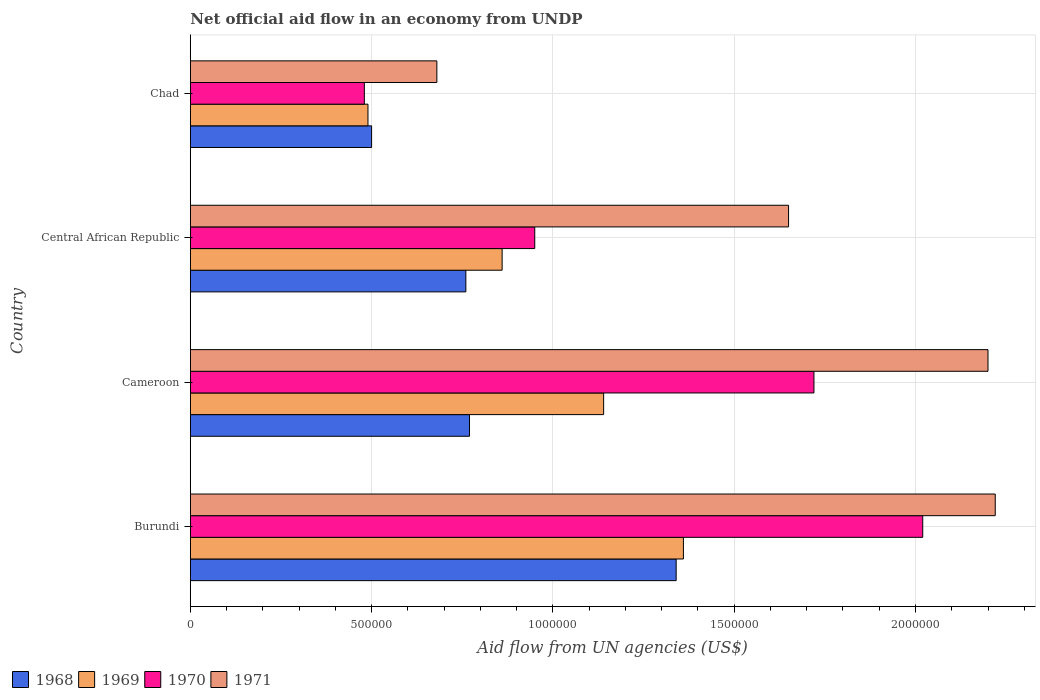How many different coloured bars are there?
Provide a succinct answer. 4. How many groups of bars are there?
Your answer should be very brief. 4. Are the number of bars per tick equal to the number of legend labels?
Offer a very short reply. Yes. Are the number of bars on each tick of the Y-axis equal?
Ensure brevity in your answer.  Yes. How many bars are there on the 4th tick from the bottom?
Make the answer very short. 4. What is the label of the 3rd group of bars from the top?
Ensure brevity in your answer.  Cameroon. In how many cases, is the number of bars for a given country not equal to the number of legend labels?
Offer a very short reply. 0. What is the net official aid flow in 1971 in Central African Republic?
Make the answer very short. 1.65e+06. Across all countries, what is the maximum net official aid flow in 1970?
Provide a short and direct response. 2.02e+06. Across all countries, what is the minimum net official aid flow in 1971?
Ensure brevity in your answer.  6.80e+05. In which country was the net official aid flow in 1971 maximum?
Make the answer very short. Burundi. In which country was the net official aid flow in 1968 minimum?
Your answer should be very brief. Chad. What is the total net official aid flow in 1968 in the graph?
Make the answer very short. 3.37e+06. What is the difference between the net official aid flow in 1971 in Cameroon and that in Chad?
Give a very brief answer. 1.52e+06. What is the difference between the net official aid flow in 1969 in Chad and the net official aid flow in 1970 in Cameroon?
Your answer should be compact. -1.23e+06. What is the average net official aid flow in 1969 per country?
Make the answer very short. 9.62e+05. What is the ratio of the net official aid flow in 1969 in Cameroon to that in Chad?
Your answer should be compact. 2.33. What is the difference between the highest and the second highest net official aid flow in 1970?
Provide a short and direct response. 3.00e+05. What is the difference between the highest and the lowest net official aid flow in 1970?
Your answer should be compact. 1.54e+06. In how many countries, is the net official aid flow in 1968 greater than the average net official aid flow in 1968 taken over all countries?
Offer a very short reply. 1. Is it the case that in every country, the sum of the net official aid flow in 1971 and net official aid flow in 1968 is greater than the sum of net official aid flow in 1969 and net official aid flow in 1970?
Provide a short and direct response. No. What does the 3rd bar from the bottom in Burundi represents?
Provide a short and direct response. 1970. Is it the case that in every country, the sum of the net official aid flow in 1970 and net official aid flow in 1971 is greater than the net official aid flow in 1968?
Your response must be concise. Yes. How many bars are there?
Give a very brief answer. 16. Are all the bars in the graph horizontal?
Your response must be concise. Yes. How many countries are there in the graph?
Make the answer very short. 4. What is the difference between two consecutive major ticks on the X-axis?
Make the answer very short. 5.00e+05. Are the values on the major ticks of X-axis written in scientific E-notation?
Offer a terse response. No. Does the graph contain any zero values?
Your answer should be compact. No. Does the graph contain grids?
Provide a short and direct response. Yes. How are the legend labels stacked?
Give a very brief answer. Horizontal. What is the title of the graph?
Your answer should be very brief. Net official aid flow in an economy from UNDP. What is the label or title of the X-axis?
Your answer should be compact. Aid flow from UN agencies (US$). What is the label or title of the Y-axis?
Offer a very short reply. Country. What is the Aid flow from UN agencies (US$) in 1968 in Burundi?
Your answer should be very brief. 1.34e+06. What is the Aid flow from UN agencies (US$) of 1969 in Burundi?
Offer a terse response. 1.36e+06. What is the Aid flow from UN agencies (US$) in 1970 in Burundi?
Offer a terse response. 2.02e+06. What is the Aid flow from UN agencies (US$) of 1971 in Burundi?
Offer a terse response. 2.22e+06. What is the Aid flow from UN agencies (US$) of 1968 in Cameroon?
Ensure brevity in your answer.  7.70e+05. What is the Aid flow from UN agencies (US$) of 1969 in Cameroon?
Your answer should be compact. 1.14e+06. What is the Aid flow from UN agencies (US$) in 1970 in Cameroon?
Provide a succinct answer. 1.72e+06. What is the Aid flow from UN agencies (US$) of 1971 in Cameroon?
Your response must be concise. 2.20e+06. What is the Aid flow from UN agencies (US$) in 1968 in Central African Republic?
Your answer should be compact. 7.60e+05. What is the Aid flow from UN agencies (US$) of 1969 in Central African Republic?
Your answer should be very brief. 8.60e+05. What is the Aid flow from UN agencies (US$) in 1970 in Central African Republic?
Your answer should be very brief. 9.50e+05. What is the Aid flow from UN agencies (US$) of 1971 in Central African Republic?
Offer a terse response. 1.65e+06. What is the Aid flow from UN agencies (US$) in 1968 in Chad?
Your answer should be compact. 5.00e+05. What is the Aid flow from UN agencies (US$) in 1969 in Chad?
Your response must be concise. 4.90e+05. What is the Aid flow from UN agencies (US$) in 1971 in Chad?
Make the answer very short. 6.80e+05. Across all countries, what is the maximum Aid flow from UN agencies (US$) in 1968?
Provide a succinct answer. 1.34e+06. Across all countries, what is the maximum Aid flow from UN agencies (US$) of 1969?
Provide a succinct answer. 1.36e+06. Across all countries, what is the maximum Aid flow from UN agencies (US$) in 1970?
Offer a very short reply. 2.02e+06. Across all countries, what is the maximum Aid flow from UN agencies (US$) of 1971?
Keep it short and to the point. 2.22e+06. Across all countries, what is the minimum Aid flow from UN agencies (US$) of 1968?
Your answer should be compact. 5.00e+05. Across all countries, what is the minimum Aid flow from UN agencies (US$) in 1969?
Ensure brevity in your answer.  4.90e+05. Across all countries, what is the minimum Aid flow from UN agencies (US$) of 1970?
Make the answer very short. 4.80e+05. Across all countries, what is the minimum Aid flow from UN agencies (US$) of 1971?
Provide a succinct answer. 6.80e+05. What is the total Aid flow from UN agencies (US$) of 1968 in the graph?
Keep it short and to the point. 3.37e+06. What is the total Aid flow from UN agencies (US$) of 1969 in the graph?
Offer a terse response. 3.85e+06. What is the total Aid flow from UN agencies (US$) of 1970 in the graph?
Give a very brief answer. 5.17e+06. What is the total Aid flow from UN agencies (US$) of 1971 in the graph?
Ensure brevity in your answer.  6.75e+06. What is the difference between the Aid flow from UN agencies (US$) in 1968 in Burundi and that in Cameroon?
Your answer should be very brief. 5.70e+05. What is the difference between the Aid flow from UN agencies (US$) of 1971 in Burundi and that in Cameroon?
Make the answer very short. 2.00e+04. What is the difference between the Aid flow from UN agencies (US$) of 1968 in Burundi and that in Central African Republic?
Provide a succinct answer. 5.80e+05. What is the difference between the Aid flow from UN agencies (US$) of 1969 in Burundi and that in Central African Republic?
Make the answer very short. 5.00e+05. What is the difference between the Aid flow from UN agencies (US$) in 1970 in Burundi and that in Central African Republic?
Keep it short and to the point. 1.07e+06. What is the difference between the Aid flow from UN agencies (US$) of 1971 in Burundi and that in Central African Republic?
Your answer should be very brief. 5.70e+05. What is the difference between the Aid flow from UN agencies (US$) of 1968 in Burundi and that in Chad?
Offer a terse response. 8.40e+05. What is the difference between the Aid flow from UN agencies (US$) of 1969 in Burundi and that in Chad?
Keep it short and to the point. 8.70e+05. What is the difference between the Aid flow from UN agencies (US$) in 1970 in Burundi and that in Chad?
Offer a terse response. 1.54e+06. What is the difference between the Aid flow from UN agencies (US$) in 1971 in Burundi and that in Chad?
Keep it short and to the point. 1.54e+06. What is the difference between the Aid flow from UN agencies (US$) in 1969 in Cameroon and that in Central African Republic?
Provide a succinct answer. 2.80e+05. What is the difference between the Aid flow from UN agencies (US$) in 1970 in Cameroon and that in Central African Republic?
Offer a very short reply. 7.70e+05. What is the difference between the Aid flow from UN agencies (US$) of 1971 in Cameroon and that in Central African Republic?
Make the answer very short. 5.50e+05. What is the difference between the Aid flow from UN agencies (US$) of 1969 in Cameroon and that in Chad?
Make the answer very short. 6.50e+05. What is the difference between the Aid flow from UN agencies (US$) of 1970 in Cameroon and that in Chad?
Make the answer very short. 1.24e+06. What is the difference between the Aid flow from UN agencies (US$) of 1971 in Cameroon and that in Chad?
Provide a short and direct response. 1.52e+06. What is the difference between the Aid flow from UN agencies (US$) of 1969 in Central African Republic and that in Chad?
Ensure brevity in your answer.  3.70e+05. What is the difference between the Aid flow from UN agencies (US$) in 1970 in Central African Republic and that in Chad?
Offer a terse response. 4.70e+05. What is the difference between the Aid flow from UN agencies (US$) of 1971 in Central African Republic and that in Chad?
Your answer should be compact. 9.70e+05. What is the difference between the Aid flow from UN agencies (US$) of 1968 in Burundi and the Aid flow from UN agencies (US$) of 1969 in Cameroon?
Keep it short and to the point. 2.00e+05. What is the difference between the Aid flow from UN agencies (US$) in 1968 in Burundi and the Aid flow from UN agencies (US$) in 1970 in Cameroon?
Make the answer very short. -3.80e+05. What is the difference between the Aid flow from UN agencies (US$) of 1968 in Burundi and the Aid flow from UN agencies (US$) of 1971 in Cameroon?
Provide a short and direct response. -8.60e+05. What is the difference between the Aid flow from UN agencies (US$) of 1969 in Burundi and the Aid flow from UN agencies (US$) of 1970 in Cameroon?
Your answer should be very brief. -3.60e+05. What is the difference between the Aid flow from UN agencies (US$) in 1969 in Burundi and the Aid flow from UN agencies (US$) in 1971 in Cameroon?
Offer a terse response. -8.40e+05. What is the difference between the Aid flow from UN agencies (US$) in 1968 in Burundi and the Aid flow from UN agencies (US$) in 1971 in Central African Republic?
Ensure brevity in your answer.  -3.10e+05. What is the difference between the Aid flow from UN agencies (US$) of 1969 in Burundi and the Aid flow from UN agencies (US$) of 1970 in Central African Republic?
Offer a terse response. 4.10e+05. What is the difference between the Aid flow from UN agencies (US$) in 1970 in Burundi and the Aid flow from UN agencies (US$) in 1971 in Central African Republic?
Provide a short and direct response. 3.70e+05. What is the difference between the Aid flow from UN agencies (US$) of 1968 in Burundi and the Aid flow from UN agencies (US$) of 1969 in Chad?
Offer a terse response. 8.50e+05. What is the difference between the Aid flow from UN agencies (US$) in 1968 in Burundi and the Aid flow from UN agencies (US$) in 1970 in Chad?
Keep it short and to the point. 8.60e+05. What is the difference between the Aid flow from UN agencies (US$) in 1968 in Burundi and the Aid flow from UN agencies (US$) in 1971 in Chad?
Make the answer very short. 6.60e+05. What is the difference between the Aid flow from UN agencies (US$) in 1969 in Burundi and the Aid flow from UN agencies (US$) in 1970 in Chad?
Keep it short and to the point. 8.80e+05. What is the difference between the Aid flow from UN agencies (US$) in 1969 in Burundi and the Aid flow from UN agencies (US$) in 1971 in Chad?
Your answer should be very brief. 6.80e+05. What is the difference between the Aid flow from UN agencies (US$) in 1970 in Burundi and the Aid flow from UN agencies (US$) in 1971 in Chad?
Your answer should be compact. 1.34e+06. What is the difference between the Aid flow from UN agencies (US$) in 1968 in Cameroon and the Aid flow from UN agencies (US$) in 1971 in Central African Republic?
Ensure brevity in your answer.  -8.80e+05. What is the difference between the Aid flow from UN agencies (US$) in 1969 in Cameroon and the Aid flow from UN agencies (US$) in 1971 in Central African Republic?
Make the answer very short. -5.10e+05. What is the difference between the Aid flow from UN agencies (US$) in 1968 in Cameroon and the Aid flow from UN agencies (US$) in 1969 in Chad?
Offer a very short reply. 2.80e+05. What is the difference between the Aid flow from UN agencies (US$) in 1970 in Cameroon and the Aid flow from UN agencies (US$) in 1971 in Chad?
Your answer should be compact. 1.04e+06. What is the difference between the Aid flow from UN agencies (US$) of 1968 in Central African Republic and the Aid flow from UN agencies (US$) of 1969 in Chad?
Keep it short and to the point. 2.70e+05. What is the difference between the Aid flow from UN agencies (US$) in 1969 in Central African Republic and the Aid flow from UN agencies (US$) in 1970 in Chad?
Offer a terse response. 3.80e+05. What is the difference between the Aid flow from UN agencies (US$) of 1969 in Central African Republic and the Aid flow from UN agencies (US$) of 1971 in Chad?
Make the answer very short. 1.80e+05. What is the average Aid flow from UN agencies (US$) in 1968 per country?
Provide a short and direct response. 8.42e+05. What is the average Aid flow from UN agencies (US$) of 1969 per country?
Provide a succinct answer. 9.62e+05. What is the average Aid flow from UN agencies (US$) in 1970 per country?
Make the answer very short. 1.29e+06. What is the average Aid flow from UN agencies (US$) in 1971 per country?
Provide a short and direct response. 1.69e+06. What is the difference between the Aid flow from UN agencies (US$) of 1968 and Aid flow from UN agencies (US$) of 1970 in Burundi?
Keep it short and to the point. -6.80e+05. What is the difference between the Aid flow from UN agencies (US$) of 1968 and Aid flow from UN agencies (US$) of 1971 in Burundi?
Your response must be concise. -8.80e+05. What is the difference between the Aid flow from UN agencies (US$) in 1969 and Aid flow from UN agencies (US$) in 1970 in Burundi?
Provide a short and direct response. -6.60e+05. What is the difference between the Aid flow from UN agencies (US$) in 1969 and Aid flow from UN agencies (US$) in 1971 in Burundi?
Offer a very short reply. -8.60e+05. What is the difference between the Aid flow from UN agencies (US$) of 1968 and Aid flow from UN agencies (US$) of 1969 in Cameroon?
Your answer should be compact. -3.70e+05. What is the difference between the Aid flow from UN agencies (US$) of 1968 and Aid flow from UN agencies (US$) of 1970 in Cameroon?
Provide a short and direct response. -9.50e+05. What is the difference between the Aid flow from UN agencies (US$) of 1968 and Aid flow from UN agencies (US$) of 1971 in Cameroon?
Provide a succinct answer. -1.43e+06. What is the difference between the Aid flow from UN agencies (US$) in 1969 and Aid flow from UN agencies (US$) in 1970 in Cameroon?
Provide a short and direct response. -5.80e+05. What is the difference between the Aid flow from UN agencies (US$) in 1969 and Aid flow from UN agencies (US$) in 1971 in Cameroon?
Provide a short and direct response. -1.06e+06. What is the difference between the Aid flow from UN agencies (US$) in 1970 and Aid flow from UN agencies (US$) in 1971 in Cameroon?
Your response must be concise. -4.80e+05. What is the difference between the Aid flow from UN agencies (US$) in 1968 and Aid flow from UN agencies (US$) in 1969 in Central African Republic?
Provide a succinct answer. -1.00e+05. What is the difference between the Aid flow from UN agencies (US$) of 1968 and Aid flow from UN agencies (US$) of 1971 in Central African Republic?
Keep it short and to the point. -8.90e+05. What is the difference between the Aid flow from UN agencies (US$) in 1969 and Aid flow from UN agencies (US$) in 1970 in Central African Republic?
Provide a short and direct response. -9.00e+04. What is the difference between the Aid flow from UN agencies (US$) of 1969 and Aid flow from UN agencies (US$) of 1971 in Central African Republic?
Give a very brief answer. -7.90e+05. What is the difference between the Aid flow from UN agencies (US$) in 1970 and Aid flow from UN agencies (US$) in 1971 in Central African Republic?
Your response must be concise. -7.00e+05. What is the difference between the Aid flow from UN agencies (US$) in 1968 and Aid flow from UN agencies (US$) in 1971 in Chad?
Your answer should be very brief. -1.80e+05. What is the difference between the Aid flow from UN agencies (US$) in 1969 and Aid flow from UN agencies (US$) in 1970 in Chad?
Provide a succinct answer. 10000. What is the ratio of the Aid flow from UN agencies (US$) in 1968 in Burundi to that in Cameroon?
Offer a terse response. 1.74. What is the ratio of the Aid flow from UN agencies (US$) in 1969 in Burundi to that in Cameroon?
Provide a short and direct response. 1.19. What is the ratio of the Aid flow from UN agencies (US$) in 1970 in Burundi to that in Cameroon?
Provide a short and direct response. 1.17. What is the ratio of the Aid flow from UN agencies (US$) of 1971 in Burundi to that in Cameroon?
Ensure brevity in your answer.  1.01. What is the ratio of the Aid flow from UN agencies (US$) in 1968 in Burundi to that in Central African Republic?
Your response must be concise. 1.76. What is the ratio of the Aid flow from UN agencies (US$) of 1969 in Burundi to that in Central African Republic?
Keep it short and to the point. 1.58. What is the ratio of the Aid flow from UN agencies (US$) of 1970 in Burundi to that in Central African Republic?
Give a very brief answer. 2.13. What is the ratio of the Aid flow from UN agencies (US$) in 1971 in Burundi to that in Central African Republic?
Your response must be concise. 1.35. What is the ratio of the Aid flow from UN agencies (US$) of 1968 in Burundi to that in Chad?
Your response must be concise. 2.68. What is the ratio of the Aid flow from UN agencies (US$) in 1969 in Burundi to that in Chad?
Offer a terse response. 2.78. What is the ratio of the Aid flow from UN agencies (US$) in 1970 in Burundi to that in Chad?
Provide a short and direct response. 4.21. What is the ratio of the Aid flow from UN agencies (US$) in 1971 in Burundi to that in Chad?
Ensure brevity in your answer.  3.26. What is the ratio of the Aid flow from UN agencies (US$) of 1968 in Cameroon to that in Central African Republic?
Your response must be concise. 1.01. What is the ratio of the Aid flow from UN agencies (US$) of 1969 in Cameroon to that in Central African Republic?
Give a very brief answer. 1.33. What is the ratio of the Aid flow from UN agencies (US$) in 1970 in Cameroon to that in Central African Republic?
Your answer should be very brief. 1.81. What is the ratio of the Aid flow from UN agencies (US$) of 1971 in Cameroon to that in Central African Republic?
Provide a succinct answer. 1.33. What is the ratio of the Aid flow from UN agencies (US$) of 1968 in Cameroon to that in Chad?
Provide a short and direct response. 1.54. What is the ratio of the Aid flow from UN agencies (US$) of 1969 in Cameroon to that in Chad?
Ensure brevity in your answer.  2.33. What is the ratio of the Aid flow from UN agencies (US$) of 1970 in Cameroon to that in Chad?
Keep it short and to the point. 3.58. What is the ratio of the Aid flow from UN agencies (US$) of 1971 in Cameroon to that in Chad?
Offer a terse response. 3.24. What is the ratio of the Aid flow from UN agencies (US$) in 1968 in Central African Republic to that in Chad?
Your answer should be very brief. 1.52. What is the ratio of the Aid flow from UN agencies (US$) in 1969 in Central African Republic to that in Chad?
Keep it short and to the point. 1.76. What is the ratio of the Aid flow from UN agencies (US$) of 1970 in Central African Republic to that in Chad?
Provide a succinct answer. 1.98. What is the ratio of the Aid flow from UN agencies (US$) in 1971 in Central African Republic to that in Chad?
Give a very brief answer. 2.43. What is the difference between the highest and the second highest Aid flow from UN agencies (US$) of 1968?
Provide a short and direct response. 5.70e+05. What is the difference between the highest and the second highest Aid flow from UN agencies (US$) of 1969?
Your response must be concise. 2.20e+05. What is the difference between the highest and the second highest Aid flow from UN agencies (US$) in 1970?
Ensure brevity in your answer.  3.00e+05. What is the difference between the highest and the second highest Aid flow from UN agencies (US$) in 1971?
Offer a very short reply. 2.00e+04. What is the difference between the highest and the lowest Aid flow from UN agencies (US$) in 1968?
Give a very brief answer. 8.40e+05. What is the difference between the highest and the lowest Aid flow from UN agencies (US$) of 1969?
Keep it short and to the point. 8.70e+05. What is the difference between the highest and the lowest Aid flow from UN agencies (US$) in 1970?
Make the answer very short. 1.54e+06. What is the difference between the highest and the lowest Aid flow from UN agencies (US$) of 1971?
Your answer should be very brief. 1.54e+06. 